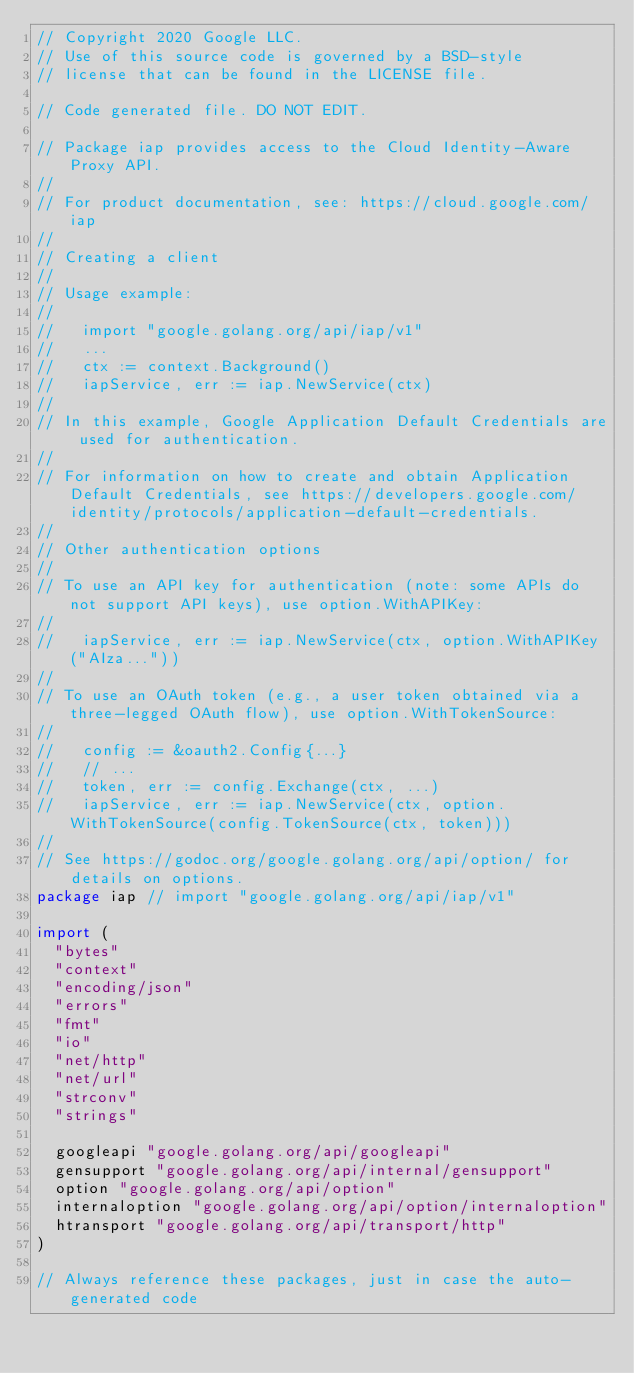<code> <loc_0><loc_0><loc_500><loc_500><_Go_>// Copyright 2020 Google LLC.
// Use of this source code is governed by a BSD-style
// license that can be found in the LICENSE file.

// Code generated file. DO NOT EDIT.

// Package iap provides access to the Cloud Identity-Aware Proxy API.
//
// For product documentation, see: https://cloud.google.com/iap
//
// Creating a client
//
// Usage example:
//
//   import "google.golang.org/api/iap/v1"
//   ...
//   ctx := context.Background()
//   iapService, err := iap.NewService(ctx)
//
// In this example, Google Application Default Credentials are used for authentication.
//
// For information on how to create and obtain Application Default Credentials, see https://developers.google.com/identity/protocols/application-default-credentials.
//
// Other authentication options
//
// To use an API key for authentication (note: some APIs do not support API keys), use option.WithAPIKey:
//
//   iapService, err := iap.NewService(ctx, option.WithAPIKey("AIza..."))
//
// To use an OAuth token (e.g., a user token obtained via a three-legged OAuth flow), use option.WithTokenSource:
//
//   config := &oauth2.Config{...}
//   // ...
//   token, err := config.Exchange(ctx, ...)
//   iapService, err := iap.NewService(ctx, option.WithTokenSource(config.TokenSource(ctx, token)))
//
// See https://godoc.org/google.golang.org/api/option/ for details on options.
package iap // import "google.golang.org/api/iap/v1"

import (
	"bytes"
	"context"
	"encoding/json"
	"errors"
	"fmt"
	"io"
	"net/http"
	"net/url"
	"strconv"
	"strings"

	googleapi "google.golang.org/api/googleapi"
	gensupport "google.golang.org/api/internal/gensupport"
	option "google.golang.org/api/option"
	internaloption "google.golang.org/api/option/internaloption"
	htransport "google.golang.org/api/transport/http"
)

// Always reference these packages, just in case the auto-generated code</code> 